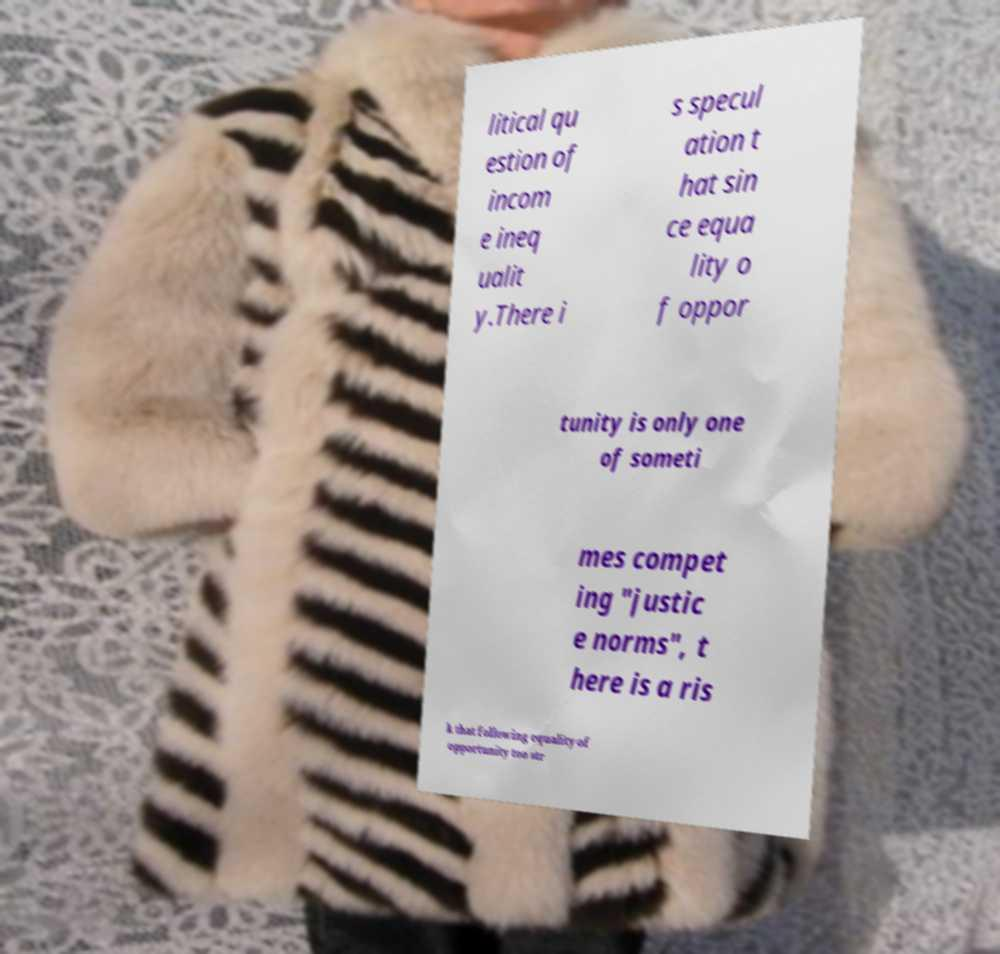For documentation purposes, I need the text within this image transcribed. Could you provide that? litical qu estion of incom e ineq ualit y.There i s specul ation t hat sin ce equa lity o f oppor tunity is only one of someti mes compet ing "justic e norms", t here is a ris k that following equality of opportunity too str 